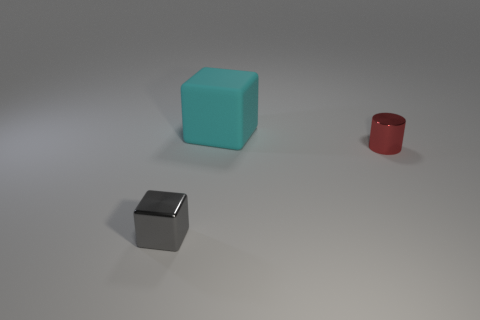How many small blue blocks are there?
Ensure brevity in your answer.  0. Are the big block and the gray thing made of the same material?
Your response must be concise. No. There is a tiny metal thing that is on the right side of the block to the right of the tiny shiny thing that is left of the big block; what is its shape?
Offer a very short reply. Cylinder. Does the tiny object on the left side of the red metal cylinder have the same material as the thing on the right side of the large matte cube?
Offer a very short reply. Yes. What is the material of the small gray thing?
Keep it short and to the point. Metal. What number of large cyan objects have the same shape as the gray object?
Provide a short and direct response. 1. Is there any other thing that has the same shape as the big cyan matte object?
Ensure brevity in your answer.  Yes. There is a cube behind the tiny metallic object to the right of the shiny object that is left of the rubber cube; what is its color?
Your answer should be very brief. Cyan. What number of small objects are cyan blocks or red shiny cubes?
Make the answer very short. 0. Are there the same number of red shiny things in front of the gray metal object and small blue matte blocks?
Provide a succinct answer. Yes. 